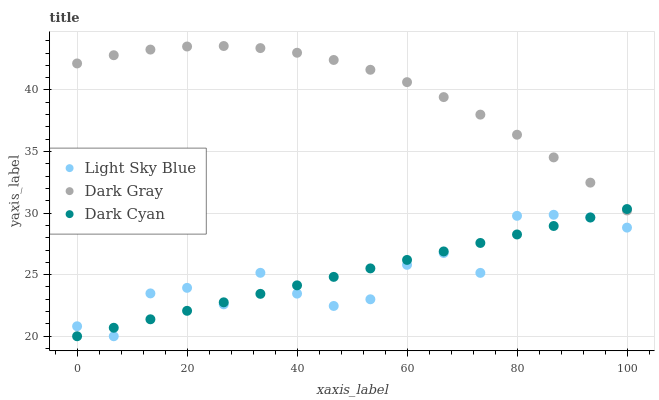Does Light Sky Blue have the minimum area under the curve?
Answer yes or no. Yes. Does Dark Gray have the maximum area under the curve?
Answer yes or no. Yes. Does Dark Cyan have the minimum area under the curve?
Answer yes or no. No. Does Dark Cyan have the maximum area under the curve?
Answer yes or no. No. Is Dark Cyan the smoothest?
Answer yes or no. Yes. Is Light Sky Blue the roughest?
Answer yes or no. Yes. Is Light Sky Blue the smoothest?
Answer yes or no. No. Is Dark Cyan the roughest?
Answer yes or no. No. Does Dark Cyan have the lowest value?
Answer yes or no. Yes. Does Dark Gray have the highest value?
Answer yes or no. Yes. Does Dark Cyan have the highest value?
Answer yes or no. No. Is Light Sky Blue less than Dark Gray?
Answer yes or no. Yes. Is Dark Gray greater than Light Sky Blue?
Answer yes or no. Yes. Does Dark Cyan intersect Light Sky Blue?
Answer yes or no. Yes. Is Dark Cyan less than Light Sky Blue?
Answer yes or no. No. Is Dark Cyan greater than Light Sky Blue?
Answer yes or no. No. Does Light Sky Blue intersect Dark Gray?
Answer yes or no. No. 